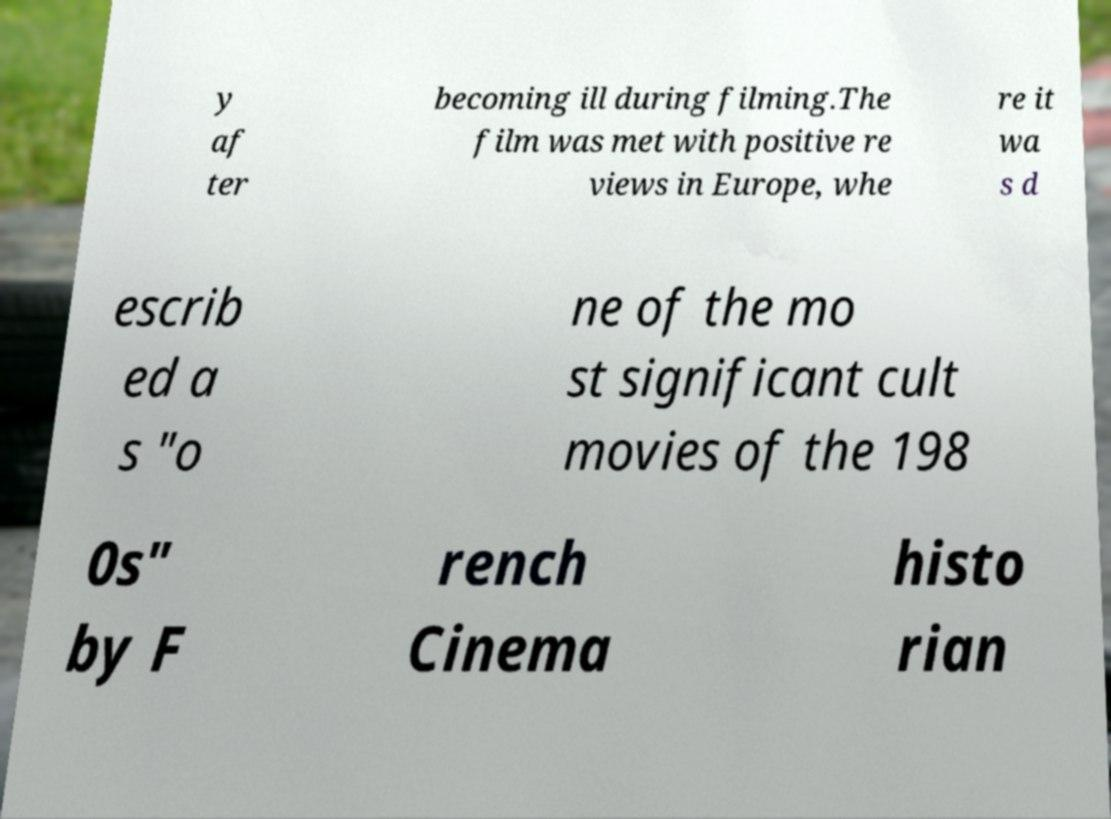I need the written content from this picture converted into text. Can you do that? y af ter becoming ill during filming.The film was met with positive re views in Europe, whe re it wa s d escrib ed a s "o ne of the mo st significant cult movies of the 198 0s" by F rench Cinema histo rian 